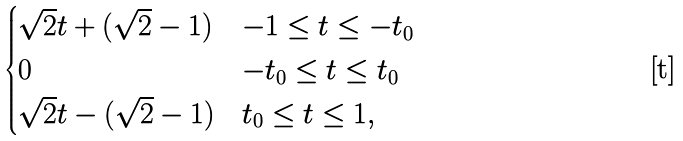<formula> <loc_0><loc_0><loc_500><loc_500>\begin{cases} \sqrt { 2 } t + ( \sqrt { 2 } - 1 ) & - 1 \leq t \leq - t _ { 0 } \\ 0 & - t _ { 0 } \leq t \leq t _ { 0 } \\ \sqrt { 2 } t - ( \sqrt { 2 } - 1 ) & t _ { 0 } \leq t \leq 1 , \end{cases}</formula> 